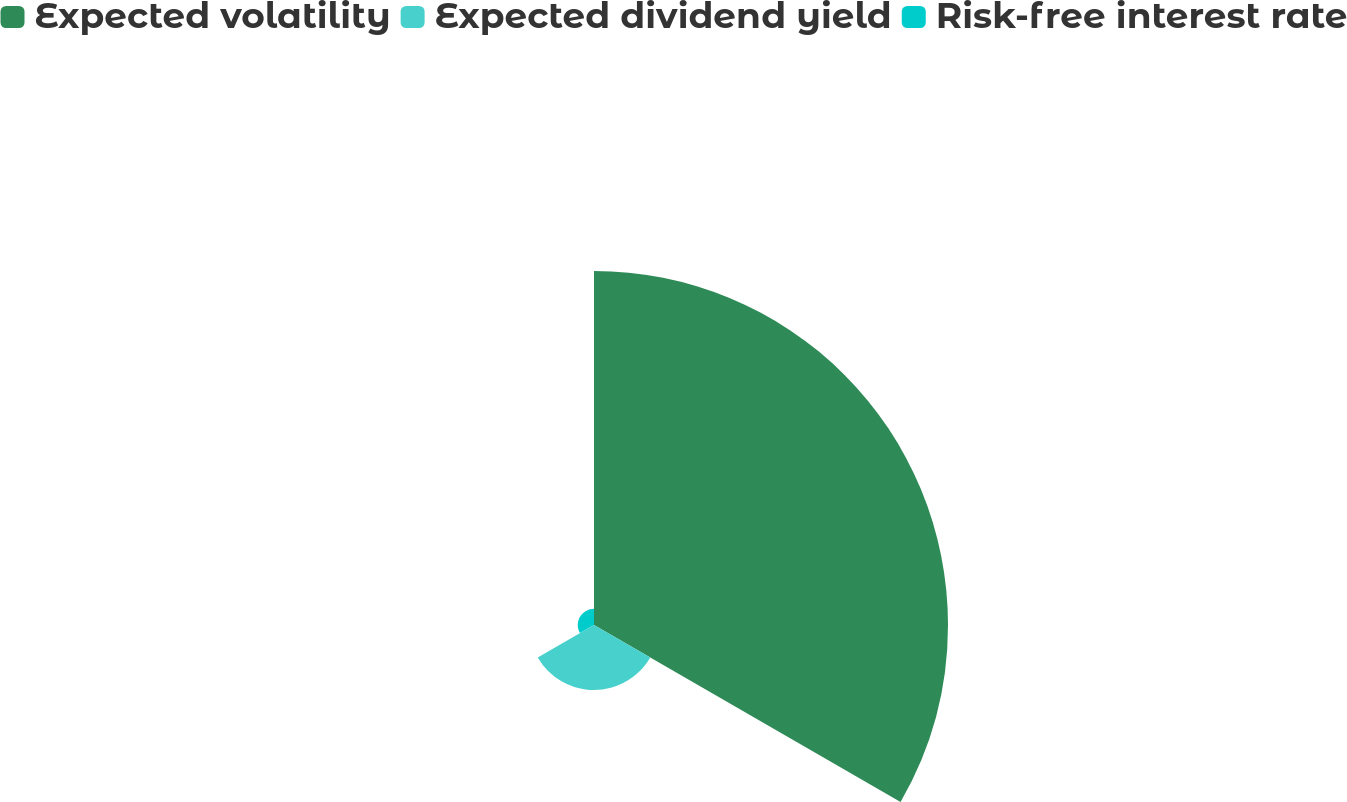<chart> <loc_0><loc_0><loc_500><loc_500><pie_chart><fcel>Expected volatility<fcel>Expected dividend yield<fcel>Risk-free interest rate<nl><fcel>81.34%<fcel>14.93%<fcel>3.73%<nl></chart> 